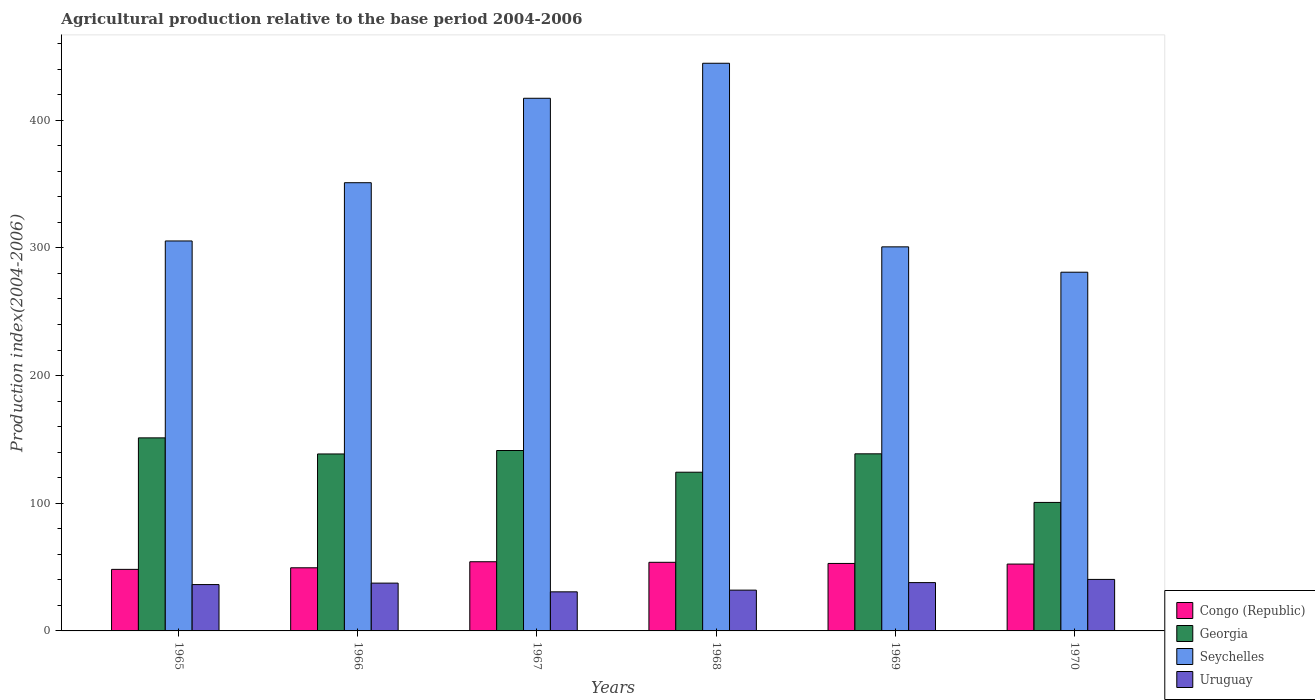How many different coloured bars are there?
Your answer should be compact. 4. Are the number of bars on each tick of the X-axis equal?
Offer a terse response. Yes. In how many cases, is the number of bars for a given year not equal to the number of legend labels?
Offer a terse response. 0. What is the agricultural production index in Uruguay in 1968?
Provide a succinct answer. 31.95. Across all years, what is the maximum agricultural production index in Congo (Republic)?
Your answer should be very brief. 54.18. Across all years, what is the minimum agricultural production index in Uruguay?
Make the answer very short. 30.61. In which year was the agricultural production index in Seychelles maximum?
Make the answer very short. 1968. In which year was the agricultural production index in Seychelles minimum?
Provide a short and direct response. 1970. What is the total agricultural production index in Uruguay in the graph?
Offer a very short reply. 214.48. What is the difference between the agricultural production index in Congo (Republic) in 1967 and that in 1970?
Keep it short and to the point. 1.82. What is the difference between the agricultural production index in Seychelles in 1966 and the agricultural production index in Uruguay in 1967?
Ensure brevity in your answer.  320.42. What is the average agricultural production index in Congo (Republic) per year?
Your answer should be compact. 51.8. In the year 1968, what is the difference between the agricultural production index in Congo (Republic) and agricultural production index in Georgia?
Keep it short and to the point. -70.56. What is the ratio of the agricultural production index in Congo (Republic) in 1965 to that in 1967?
Give a very brief answer. 0.89. What is the difference between the highest and the second highest agricultural production index in Congo (Republic)?
Provide a succinct answer. 0.44. What is the difference between the highest and the lowest agricultural production index in Uruguay?
Your answer should be compact. 9.73. In how many years, is the agricultural production index in Uruguay greater than the average agricultural production index in Uruguay taken over all years?
Your answer should be very brief. 4. Is the sum of the agricultural production index in Georgia in 1966 and 1969 greater than the maximum agricultural production index in Congo (Republic) across all years?
Your answer should be very brief. Yes. Is it the case that in every year, the sum of the agricultural production index in Uruguay and agricultural production index in Seychelles is greater than the sum of agricultural production index in Georgia and agricultural production index in Congo (Republic)?
Provide a succinct answer. Yes. What does the 4th bar from the left in 1970 represents?
Make the answer very short. Uruguay. What does the 2nd bar from the right in 1967 represents?
Make the answer very short. Seychelles. Is it the case that in every year, the sum of the agricultural production index in Congo (Republic) and agricultural production index in Seychelles is greater than the agricultural production index in Uruguay?
Your answer should be compact. Yes. How many bars are there?
Keep it short and to the point. 24. Are all the bars in the graph horizontal?
Ensure brevity in your answer.  No. Does the graph contain any zero values?
Make the answer very short. No. How are the legend labels stacked?
Provide a succinct answer. Vertical. What is the title of the graph?
Offer a very short reply. Agricultural production relative to the base period 2004-2006. Does "Moldova" appear as one of the legend labels in the graph?
Your answer should be compact. No. What is the label or title of the Y-axis?
Provide a succinct answer. Production index(2004-2006). What is the Production index(2004-2006) in Congo (Republic) in 1965?
Offer a terse response. 48.21. What is the Production index(2004-2006) in Georgia in 1965?
Offer a very short reply. 151.2. What is the Production index(2004-2006) of Seychelles in 1965?
Give a very brief answer. 305.41. What is the Production index(2004-2006) in Uruguay in 1965?
Make the answer very short. 36.3. What is the Production index(2004-2006) in Congo (Republic) in 1966?
Keep it short and to the point. 49.44. What is the Production index(2004-2006) in Georgia in 1966?
Give a very brief answer. 138.6. What is the Production index(2004-2006) in Seychelles in 1966?
Offer a very short reply. 351.03. What is the Production index(2004-2006) of Uruguay in 1966?
Offer a terse response. 37.44. What is the Production index(2004-2006) of Congo (Republic) in 1967?
Your answer should be compact. 54.18. What is the Production index(2004-2006) of Georgia in 1967?
Offer a terse response. 141.3. What is the Production index(2004-2006) of Seychelles in 1967?
Offer a terse response. 417.17. What is the Production index(2004-2006) of Uruguay in 1967?
Give a very brief answer. 30.61. What is the Production index(2004-2006) in Congo (Republic) in 1968?
Provide a succinct answer. 53.74. What is the Production index(2004-2006) of Georgia in 1968?
Your response must be concise. 124.3. What is the Production index(2004-2006) in Seychelles in 1968?
Your response must be concise. 444.59. What is the Production index(2004-2006) in Uruguay in 1968?
Offer a very short reply. 31.95. What is the Production index(2004-2006) in Congo (Republic) in 1969?
Provide a succinct answer. 52.85. What is the Production index(2004-2006) in Georgia in 1969?
Your answer should be very brief. 138.7. What is the Production index(2004-2006) of Seychelles in 1969?
Your answer should be very brief. 300.8. What is the Production index(2004-2006) of Uruguay in 1969?
Ensure brevity in your answer.  37.84. What is the Production index(2004-2006) of Congo (Republic) in 1970?
Provide a short and direct response. 52.36. What is the Production index(2004-2006) in Georgia in 1970?
Make the answer very short. 100.63. What is the Production index(2004-2006) of Seychelles in 1970?
Ensure brevity in your answer.  280.94. What is the Production index(2004-2006) of Uruguay in 1970?
Your response must be concise. 40.34. Across all years, what is the maximum Production index(2004-2006) of Congo (Republic)?
Offer a terse response. 54.18. Across all years, what is the maximum Production index(2004-2006) of Georgia?
Your answer should be very brief. 151.2. Across all years, what is the maximum Production index(2004-2006) of Seychelles?
Offer a very short reply. 444.59. Across all years, what is the maximum Production index(2004-2006) in Uruguay?
Ensure brevity in your answer.  40.34. Across all years, what is the minimum Production index(2004-2006) in Congo (Republic)?
Give a very brief answer. 48.21. Across all years, what is the minimum Production index(2004-2006) in Georgia?
Offer a terse response. 100.63. Across all years, what is the minimum Production index(2004-2006) in Seychelles?
Provide a short and direct response. 280.94. Across all years, what is the minimum Production index(2004-2006) in Uruguay?
Provide a succinct answer. 30.61. What is the total Production index(2004-2006) of Congo (Republic) in the graph?
Offer a terse response. 310.78. What is the total Production index(2004-2006) in Georgia in the graph?
Keep it short and to the point. 794.73. What is the total Production index(2004-2006) of Seychelles in the graph?
Offer a very short reply. 2099.94. What is the total Production index(2004-2006) in Uruguay in the graph?
Your response must be concise. 214.48. What is the difference between the Production index(2004-2006) in Congo (Republic) in 1965 and that in 1966?
Keep it short and to the point. -1.23. What is the difference between the Production index(2004-2006) of Georgia in 1965 and that in 1966?
Your response must be concise. 12.6. What is the difference between the Production index(2004-2006) in Seychelles in 1965 and that in 1966?
Your answer should be very brief. -45.62. What is the difference between the Production index(2004-2006) of Uruguay in 1965 and that in 1966?
Give a very brief answer. -1.14. What is the difference between the Production index(2004-2006) of Congo (Republic) in 1965 and that in 1967?
Provide a succinct answer. -5.97. What is the difference between the Production index(2004-2006) in Seychelles in 1965 and that in 1967?
Offer a very short reply. -111.76. What is the difference between the Production index(2004-2006) in Uruguay in 1965 and that in 1967?
Offer a very short reply. 5.69. What is the difference between the Production index(2004-2006) in Congo (Republic) in 1965 and that in 1968?
Provide a short and direct response. -5.53. What is the difference between the Production index(2004-2006) of Georgia in 1965 and that in 1968?
Offer a terse response. 26.9. What is the difference between the Production index(2004-2006) in Seychelles in 1965 and that in 1968?
Your response must be concise. -139.18. What is the difference between the Production index(2004-2006) of Uruguay in 1965 and that in 1968?
Your response must be concise. 4.35. What is the difference between the Production index(2004-2006) of Congo (Republic) in 1965 and that in 1969?
Provide a succinct answer. -4.64. What is the difference between the Production index(2004-2006) of Georgia in 1965 and that in 1969?
Give a very brief answer. 12.5. What is the difference between the Production index(2004-2006) in Seychelles in 1965 and that in 1969?
Make the answer very short. 4.61. What is the difference between the Production index(2004-2006) in Uruguay in 1965 and that in 1969?
Your answer should be very brief. -1.54. What is the difference between the Production index(2004-2006) of Congo (Republic) in 1965 and that in 1970?
Make the answer very short. -4.15. What is the difference between the Production index(2004-2006) in Georgia in 1965 and that in 1970?
Provide a short and direct response. 50.57. What is the difference between the Production index(2004-2006) of Seychelles in 1965 and that in 1970?
Your answer should be compact. 24.47. What is the difference between the Production index(2004-2006) in Uruguay in 1965 and that in 1970?
Your answer should be very brief. -4.04. What is the difference between the Production index(2004-2006) in Congo (Republic) in 1966 and that in 1967?
Provide a short and direct response. -4.74. What is the difference between the Production index(2004-2006) in Seychelles in 1966 and that in 1967?
Keep it short and to the point. -66.14. What is the difference between the Production index(2004-2006) of Uruguay in 1966 and that in 1967?
Give a very brief answer. 6.83. What is the difference between the Production index(2004-2006) in Congo (Republic) in 1966 and that in 1968?
Give a very brief answer. -4.3. What is the difference between the Production index(2004-2006) in Seychelles in 1966 and that in 1968?
Offer a very short reply. -93.56. What is the difference between the Production index(2004-2006) of Uruguay in 1966 and that in 1968?
Make the answer very short. 5.49. What is the difference between the Production index(2004-2006) in Congo (Republic) in 1966 and that in 1969?
Give a very brief answer. -3.41. What is the difference between the Production index(2004-2006) in Georgia in 1966 and that in 1969?
Your answer should be compact. -0.1. What is the difference between the Production index(2004-2006) in Seychelles in 1966 and that in 1969?
Your response must be concise. 50.23. What is the difference between the Production index(2004-2006) of Uruguay in 1966 and that in 1969?
Your response must be concise. -0.4. What is the difference between the Production index(2004-2006) in Congo (Republic) in 1966 and that in 1970?
Provide a short and direct response. -2.92. What is the difference between the Production index(2004-2006) in Georgia in 1966 and that in 1970?
Ensure brevity in your answer.  37.97. What is the difference between the Production index(2004-2006) in Seychelles in 1966 and that in 1970?
Provide a short and direct response. 70.09. What is the difference between the Production index(2004-2006) of Congo (Republic) in 1967 and that in 1968?
Keep it short and to the point. 0.44. What is the difference between the Production index(2004-2006) of Georgia in 1967 and that in 1968?
Provide a succinct answer. 17. What is the difference between the Production index(2004-2006) in Seychelles in 1967 and that in 1968?
Give a very brief answer. -27.42. What is the difference between the Production index(2004-2006) of Uruguay in 1967 and that in 1968?
Offer a terse response. -1.34. What is the difference between the Production index(2004-2006) of Congo (Republic) in 1967 and that in 1969?
Ensure brevity in your answer.  1.33. What is the difference between the Production index(2004-2006) of Georgia in 1967 and that in 1969?
Offer a very short reply. 2.6. What is the difference between the Production index(2004-2006) in Seychelles in 1967 and that in 1969?
Your answer should be compact. 116.37. What is the difference between the Production index(2004-2006) of Uruguay in 1967 and that in 1969?
Keep it short and to the point. -7.23. What is the difference between the Production index(2004-2006) in Congo (Republic) in 1967 and that in 1970?
Make the answer very short. 1.82. What is the difference between the Production index(2004-2006) of Georgia in 1967 and that in 1970?
Provide a succinct answer. 40.67. What is the difference between the Production index(2004-2006) in Seychelles in 1967 and that in 1970?
Keep it short and to the point. 136.23. What is the difference between the Production index(2004-2006) of Uruguay in 1967 and that in 1970?
Make the answer very short. -9.73. What is the difference between the Production index(2004-2006) in Congo (Republic) in 1968 and that in 1969?
Make the answer very short. 0.89. What is the difference between the Production index(2004-2006) of Georgia in 1968 and that in 1969?
Your response must be concise. -14.4. What is the difference between the Production index(2004-2006) of Seychelles in 1968 and that in 1969?
Provide a succinct answer. 143.79. What is the difference between the Production index(2004-2006) in Uruguay in 1968 and that in 1969?
Keep it short and to the point. -5.89. What is the difference between the Production index(2004-2006) of Congo (Republic) in 1968 and that in 1970?
Make the answer very short. 1.38. What is the difference between the Production index(2004-2006) of Georgia in 1968 and that in 1970?
Offer a terse response. 23.67. What is the difference between the Production index(2004-2006) in Seychelles in 1968 and that in 1970?
Your answer should be compact. 163.65. What is the difference between the Production index(2004-2006) of Uruguay in 1968 and that in 1970?
Provide a short and direct response. -8.39. What is the difference between the Production index(2004-2006) of Congo (Republic) in 1969 and that in 1970?
Provide a short and direct response. 0.49. What is the difference between the Production index(2004-2006) of Georgia in 1969 and that in 1970?
Give a very brief answer. 38.07. What is the difference between the Production index(2004-2006) in Seychelles in 1969 and that in 1970?
Offer a very short reply. 19.86. What is the difference between the Production index(2004-2006) of Uruguay in 1969 and that in 1970?
Provide a short and direct response. -2.5. What is the difference between the Production index(2004-2006) in Congo (Republic) in 1965 and the Production index(2004-2006) in Georgia in 1966?
Keep it short and to the point. -90.39. What is the difference between the Production index(2004-2006) of Congo (Republic) in 1965 and the Production index(2004-2006) of Seychelles in 1966?
Your answer should be very brief. -302.82. What is the difference between the Production index(2004-2006) of Congo (Republic) in 1965 and the Production index(2004-2006) of Uruguay in 1966?
Offer a terse response. 10.77. What is the difference between the Production index(2004-2006) of Georgia in 1965 and the Production index(2004-2006) of Seychelles in 1966?
Offer a terse response. -199.83. What is the difference between the Production index(2004-2006) of Georgia in 1965 and the Production index(2004-2006) of Uruguay in 1966?
Keep it short and to the point. 113.76. What is the difference between the Production index(2004-2006) in Seychelles in 1965 and the Production index(2004-2006) in Uruguay in 1966?
Your answer should be very brief. 267.97. What is the difference between the Production index(2004-2006) in Congo (Republic) in 1965 and the Production index(2004-2006) in Georgia in 1967?
Offer a very short reply. -93.09. What is the difference between the Production index(2004-2006) in Congo (Republic) in 1965 and the Production index(2004-2006) in Seychelles in 1967?
Offer a terse response. -368.96. What is the difference between the Production index(2004-2006) of Georgia in 1965 and the Production index(2004-2006) of Seychelles in 1967?
Make the answer very short. -265.97. What is the difference between the Production index(2004-2006) in Georgia in 1965 and the Production index(2004-2006) in Uruguay in 1967?
Give a very brief answer. 120.59. What is the difference between the Production index(2004-2006) in Seychelles in 1965 and the Production index(2004-2006) in Uruguay in 1967?
Your response must be concise. 274.8. What is the difference between the Production index(2004-2006) in Congo (Republic) in 1965 and the Production index(2004-2006) in Georgia in 1968?
Your answer should be very brief. -76.09. What is the difference between the Production index(2004-2006) in Congo (Republic) in 1965 and the Production index(2004-2006) in Seychelles in 1968?
Keep it short and to the point. -396.38. What is the difference between the Production index(2004-2006) of Congo (Republic) in 1965 and the Production index(2004-2006) of Uruguay in 1968?
Keep it short and to the point. 16.26. What is the difference between the Production index(2004-2006) in Georgia in 1965 and the Production index(2004-2006) in Seychelles in 1968?
Keep it short and to the point. -293.39. What is the difference between the Production index(2004-2006) in Georgia in 1965 and the Production index(2004-2006) in Uruguay in 1968?
Ensure brevity in your answer.  119.25. What is the difference between the Production index(2004-2006) of Seychelles in 1965 and the Production index(2004-2006) of Uruguay in 1968?
Your answer should be very brief. 273.46. What is the difference between the Production index(2004-2006) in Congo (Republic) in 1965 and the Production index(2004-2006) in Georgia in 1969?
Your answer should be compact. -90.49. What is the difference between the Production index(2004-2006) in Congo (Republic) in 1965 and the Production index(2004-2006) in Seychelles in 1969?
Make the answer very short. -252.59. What is the difference between the Production index(2004-2006) of Congo (Republic) in 1965 and the Production index(2004-2006) of Uruguay in 1969?
Ensure brevity in your answer.  10.37. What is the difference between the Production index(2004-2006) in Georgia in 1965 and the Production index(2004-2006) in Seychelles in 1969?
Provide a short and direct response. -149.6. What is the difference between the Production index(2004-2006) in Georgia in 1965 and the Production index(2004-2006) in Uruguay in 1969?
Keep it short and to the point. 113.36. What is the difference between the Production index(2004-2006) in Seychelles in 1965 and the Production index(2004-2006) in Uruguay in 1969?
Give a very brief answer. 267.57. What is the difference between the Production index(2004-2006) of Congo (Republic) in 1965 and the Production index(2004-2006) of Georgia in 1970?
Give a very brief answer. -52.42. What is the difference between the Production index(2004-2006) in Congo (Republic) in 1965 and the Production index(2004-2006) in Seychelles in 1970?
Your response must be concise. -232.73. What is the difference between the Production index(2004-2006) of Congo (Republic) in 1965 and the Production index(2004-2006) of Uruguay in 1970?
Keep it short and to the point. 7.87. What is the difference between the Production index(2004-2006) in Georgia in 1965 and the Production index(2004-2006) in Seychelles in 1970?
Provide a short and direct response. -129.74. What is the difference between the Production index(2004-2006) of Georgia in 1965 and the Production index(2004-2006) of Uruguay in 1970?
Your answer should be very brief. 110.86. What is the difference between the Production index(2004-2006) of Seychelles in 1965 and the Production index(2004-2006) of Uruguay in 1970?
Give a very brief answer. 265.07. What is the difference between the Production index(2004-2006) in Congo (Republic) in 1966 and the Production index(2004-2006) in Georgia in 1967?
Keep it short and to the point. -91.86. What is the difference between the Production index(2004-2006) of Congo (Republic) in 1966 and the Production index(2004-2006) of Seychelles in 1967?
Provide a short and direct response. -367.73. What is the difference between the Production index(2004-2006) in Congo (Republic) in 1966 and the Production index(2004-2006) in Uruguay in 1967?
Your response must be concise. 18.83. What is the difference between the Production index(2004-2006) of Georgia in 1966 and the Production index(2004-2006) of Seychelles in 1967?
Give a very brief answer. -278.57. What is the difference between the Production index(2004-2006) of Georgia in 1966 and the Production index(2004-2006) of Uruguay in 1967?
Keep it short and to the point. 107.99. What is the difference between the Production index(2004-2006) of Seychelles in 1966 and the Production index(2004-2006) of Uruguay in 1967?
Your response must be concise. 320.42. What is the difference between the Production index(2004-2006) of Congo (Republic) in 1966 and the Production index(2004-2006) of Georgia in 1968?
Your response must be concise. -74.86. What is the difference between the Production index(2004-2006) in Congo (Republic) in 1966 and the Production index(2004-2006) in Seychelles in 1968?
Make the answer very short. -395.15. What is the difference between the Production index(2004-2006) in Congo (Republic) in 1966 and the Production index(2004-2006) in Uruguay in 1968?
Keep it short and to the point. 17.49. What is the difference between the Production index(2004-2006) of Georgia in 1966 and the Production index(2004-2006) of Seychelles in 1968?
Ensure brevity in your answer.  -305.99. What is the difference between the Production index(2004-2006) in Georgia in 1966 and the Production index(2004-2006) in Uruguay in 1968?
Your answer should be compact. 106.65. What is the difference between the Production index(2004-2006) in Seychelles in 1966 and the Production index(2004-2006) in Uruguay in 1968?
Make the answer very short. 319.08. What is the difference between the Production index(2004-2006) of Congo (Republic) in 1966 and the Production index(2004-2006) of Georgia in 1969?
Provide a short and direct response. -89.26. What is the difference between the Production index(2004-2006) in Congo (Republic) in 1966 and the Production index(2004-2006) in Seychelles in 1969?
Provide a short and direct response. -251.36. What is the difference between the Production index(2004-2006) of Georgia in 1966 and the Production index(2004-2006) of Seychelles in 1969?
Your response must be concise. -162.2. What is the difference between the Production index(2004-2006) of Georgia in 1966 and the Production index(2004-2006) of Uruguay in 1969?
Provide a short and direct response. 100.76. What is the difference between the Production index(2004-2006) in Seychelles in 1966 and the Production index(2004-2006) in Uruguay in 1969?
Offer a very short reply. 313.19. What is the difference between the Production index(2004-2006) of Congo (Republic) in 1966 and the Production index(2004-2006) of Georgia in 1970?
Make the answer very short. -51.19. What is the difference between the Production index(2004-2006) in Congo (Republic) in 1966 and the Production index(2004-2006) in Seychelles in 1970?
Keep it short and to the point. -231.5. What is the difference between the Production index(2004-2006) in Congo (Republic) in 1966 and the Production index(2004-2006) in Uruguay in 1970?
Offer a very short reply. 9.1. What is the difference between the Production index(2004-2006) of Georgia in 1966 and the Production index(2004-2006) of Seychelles in 1970?
Offer a very short reply. -142.34. What is the difference between the Production index(2004-2006) in Georgia in 1966 and the Production index(2004-2006) in Uruguay in 1970?
Give a very brief answer. 98.26. What is the difference between the Production index(2004-2006) in Seychelles in 1966 and the Production index(2004-2006) in Uruguay in 1970?
Make the answer very short. 310.69. What is the difference between the Production index(2004-2006) of Congo (Republic) in 1967 and the Production index(2004-2006) of Georgia in 1968?
Give a very brief answer. -70.12. What is the difference between the Production index(2004-2006) in Congo (Republic) in 1967 and the Production index(2004-2006) in Seychelles in 1968?
Your answer should be very brief. -390.41. What is the difference between the Production index(2004-2006) in Congo (Republic) in 1967 and the Production index(2004-2006) in Uruguay in 1968?
Make the answer very short. 22.23. What is the difference between the Production index(2004-2006) in Georgia in 1967 and the Production index(2004-2006) in Seychelles in 1968?
Your answer should be compact. -303.29. What is the difference between the Production index(2004-2006) of Georgia in 1967 and the Production index(2004-2006) of Uruguay in 1968?
Make the answer very short. 109.35. What is the difference between the Production index(2004-2006) in Seychelles in 1967 and the Production index(2004-2006) in Uruguay in 1968?
Your answer should be very brief. 385.22. What is the difference between the Production index(2004-2006) in Congo (Republic) in 1967 and the Production index(2004-2006) in Georgia in 1969?
Offer a terse response. -84.52. What is the difference between the Production index(2004-2006) of Congo (Republic) in 1967 and the Production index(2004-2006) of Seychelles in 1969?
Your answer should be compact. -246.62. What is the difference between the Production index(2004-2006) of Congo (Republic) in 1967 and the Production index(2004-2006) of Uruguay in 1969?
Make the answer very short. 16.34. What is the difference between the Production index(2004-2006) of Georgia in 1967 and the Production index(2004-2006) of Seychelles in 1969?
Provide a short and direct response. -159.5. What is the difference between the Production index(2004-2006) of Georgia in 1967 and the Production index(2004-2006) of Uruguay in 1969?
Offer a terse response. 103.46. What is the difference between the Production index(2004-2006) in Seychelles in 1967 and the Production index(2004-2006) in Uruguay in 1969?
Offer a very short reply. 379.33. What is the difference between the Production index(2004-2006) of Congo (Republic) in 1967 and the Production index(2004-2006) of Georgia in 1970?
Your answer should be very brief. -46.45. What is the difference between the Production index(2004-2006) in Congo (Republic) in 1967 and the Production index(2004-2006) in Seychelles in 1970?
Keep it short and to the point. -226.76. What is the difference between the Production index(2004-2006) in Congo (Republic) in 1967 and the Production index(2004-2006) in Uruguay in 1970?
Provide a short and direct response. 13.84. What is the difference between the Production index(2004-2006) in Georgia in 1967 and the Production index(2004-2006) in Seychelles in 1970?
Keep it short and to the point. -139.64. What is the difference between the Production index(2004-2006) in Georgia in 1967 and the Production index(2004-2006) in Uruguay in 1970?
Ensure brevity in your answer.  100.96. What is the difference between the Production index(2004-2006) of Seychelles in 1967 and the Production index(2004-2006) of Uruguay in 1970?
Ensure brevity in your answer.  376.83. What is the difference between the Production index(2004-2006) of Congo (Republic) in 1968 and the Production index(2004-2006) of Georgia in 1969?
Ensure brevity in your answer.  -84.96. What is the difference between the Production index(2004-2006) in Congo (Republic) in 1968 and the Production index(2004-2006) in Seychelles in 1969?
Keep it short and to the point. -247.06. What is the difference between the Production index(2004-2006) of Georgia in 1968 and the Production index(2004-2006) of Seychelles in 1969?
Offer a terse response. -176.5. What is the difference between the Production index(2004-2006) in Georgia in 1968 and the Production index(2004-2006) in Uruguay in 1969?
Ensure brevity in your answer.  86.46. What is the difference between the Production index(2004-2006) in Seychelles in 1968 and the Production index(2004-2006) in Uruguay in 1969?
Your answer should be compact. 406.75. What is the difference between the Production index(2004-2006) in Congo (Republic) in 1968 and the Production index(2004-2006) in Georgia in 1970?
Your response must be concise. -46.89. What is the difference between the Production index(2004-2006) of Congo (Republic) in 1968 and the Production index(2004-2006) of Seychelles in 1970?
Ensure brevity in your answer.  -227.2. What is the difference between the Production index(2004-2006) of Congo (Republic) in 1968 and the Production index(2004-2006) of Uruguay in 1970?
Your answer should be very brief. 13.4. What is the difference between the Production index(2004-2006) of Georgia in 1968 and the Production index(2004-2006) of Seychelles in 1970?
Provide a succinct answer. -156.64. What is the difference between the Production index(2004-2006) of Georgia in 1968 and the Production index(2004-2006) of Uruguay in 1970?
Provide a short and direct response. 83.96. What is the difference between the Production index(2004-2006) of Seychelles in 1968 and the Production index(2004-2006) of Uruguay in 1970?
Ensure brevity in your answer.  404.25. What is the difference between the Production index(2004-2006) in Congo (Republic) in 1969 and the Production index(2004-2006) in Georgia in 1970?
Your response must be concise. -47.78. What is the difference between the Production index(2004-2006) in Congo (Republic) in 1969 and the Production index(2004-2006) in Seychelles in 1970?
Your response must be concise. -228.09. What is the difference between the Production index(2004-2006) of Congo (Republic) in 1969 and the Production index(2004-2006) of Uruguay in 1970?
Your response must be concise. 12.51. What is the difference between the Production index(2004-2006) in Georgia in 1969 and the Production index(2004-2006) in Seychelles in 1970?
Offer a terse response. -142.24. What is the difference between the Production index(2004-2006) in Georgia in 1969 and the Production index(2004-2006) in Uruguay in 1970?
Offer a very short reply. 98.36. What is the difference between the Production index(2004-2006) of Seychelles in 1969 and the Production index(2004-2006) of Uruguay in 1970?
Your response must be concise. 260.46. What is the average Production index(2004-2006) of Congo (Republic) per year?
Make the answer very short. 51.8. What is the average Production index(2004-2006) of Georgia per year?
Your answer should be compact. 132.46. What is the average Production index(2004-2006) in Seychelles per year?
Offer a terse response. 349.99. What is the average Production index(2004-2006) of Uruguay per year?
Ensure brevity in your answer.  35.75. In the year 1965, what is the difference between the Production index(2004-2006) in Congo (Republic) and Production index(2004-2006) in Georgia?
Offer a terse response. -102.99. In the year 1965, what is the difference between the Production index(2004-2006) of Congo (Republic) and Production index(2004-2006) of Seychelles?
Your answer should be very brief. -257.2. In the year 1965, what is the difference between the Production index(2004-2006) in Congo (Republic) and Production index(2004-2006) in Uruguay?
Make the answer very short. 11.91. In the year 1965, what is the difference between the Production index(2004-2006) in Georgia and Production index(2004-2006) in Seychelles?
Your answer should be compact. -154.21. In the year 1965, what is the difference between the Production index(2004-2006) of Georgia and Production index(2004-2006) of Uruguay?
Offer a very short reply. 114.9. In the year 1965, what is the difference between the Production index(2004-2006) in Seychelles and Production index(2004-2006) in Uruguay?
Keep it short and to the point. 269.11. In the year 1966, what is the difference between the Production index(2004-2006) in Congo (Republic) and Production index(2004-2006) in Georgia?
Your answer should be very brief. -89.16. In the year 1966, what is the difference between the Production index(2004-2006) of Congo (Republic) and Production index(2004-2006) of Seychelles?
Your answer should be very brief. -301.59. In the year 1966, what is the difference between the Production index(2004-2006) in Georgia and Production index(2004-2006) in Seychelles?
Give a very brief answer. -212.43. In the year 1966, what is the difference between the Production index(2004-2006) of Georgia and Production index(2004-2006) of Uruguay?
Ensure brevity in your answer.  101.16. In the year 1966, what is the difference between the Production index(2004-2006) in Seychelles and Production index(2004-2006) in Uruguay?
Your response must be concise. 313.59. In the year 1967, what is the difference between the Production index(2004-2006) in Congo (Republic) and Production index(2004-2006) in Georgia?
Offer a very short reply. -87.12. In the year 1967, what is the difference between the Production index(2004-2006) of Congo (Republic) and Production index(2004-2006) of Seychelles?
Provide a succinct answer. -362.99. In the year 1967, what is the difference between the Production index(2004-2006) of Congo (Republic) and Production index(2004-2006) of Uruguay?
Ensure brevity in your answer.  23.57. In the year 1967, what is the difference between the Production index(2004-2006) in Georgia and Production index(2004-2006) in Seychelles?
Provide a short and direct response. -275.87. In the year 1967, what is the difference between the Production index(2004-2006) in Georgia and Production index(2004-2006) in Uruguay?
Ensure brevity in your answer.  110.69. In the year 1967, what is the difference between the Production index(2004-2006) in Seychelles and Production index(2004-2006) in Uruguay?
Offer a terse response. 386.56. In the year 1968, what is the difference between the Production index(2004-2006) in Congo (Republic) and Production index(2004-2006) in Georgia?
Offer a very short reply. -70.56. In the year 1968, what is the difference between the Production index(2004-2006) of Congo (Republic) and Production index(2004-2006) of Seychelles?
Offer a very short reply. -390.85. In the year 1968, what is the difference between the Production index(2004-2006) of Congo (Republic) and Production index(2004-2006) of Uruguay?
Your answer should be compact. 21.79. In the year 1968, what is the difference between the Production index(2004-2006) in Georgia and Production index(2004-2006) in Seychelles?
Your response must be concise. -320.29. In the year 1968, what is the difference between the Production index(2004-2006) of Georgia and Production index(2004-2006) of Uruguay?
Provide a short and direct response. 92.35. In the year 1968, what is the difference between the Production index(2004-2006) in Seychelles and Production index(2004-2006) in Uruguay?
Your response must be concise. 412.64. In the year 1969, what is the difference between the Production index(2004-2006) in Congo (Republic) and Production index(2004-2006) in Georgia?
Your answer should be very brief. -85.85. In the year 1969, what is the difference between the Production index(2004-2006) in Congo (Republic) and Production index(2004-2006) in Seychelles?
Provide a short and direct response. -247.95. In the year 1969, what is the difference between the Production index(2004-2006) in Congo (Republic) and Production index(2004-2006) in Uruguay?
Your answer should be very brief. 15.01. In the year 1969, what is the difference between the Production index(2004-2006) of Georgia and Production index(2004-2006) of Seychelles?
Ensure brevity in your answer.  -162.1. In the year 1969, what is the difference between the Production index(2004-2006) in Georgia and Production index(2004-2006) in Uruguay?
Offer a very short reply. 100.86. In the year 1969, what is the difference between the Production index(2004-2006) of Seychelles and Production index(2004-2006) of Uruguay?
Ensure brevity in your answer.  262.96. In the year 1970, what is the difference between the Production index(2004-2006) in Congo (Republic) and Production index(2004-2006) in Georgia?
Make the answer very short. -48.27. In the year 1970, what is the difference between the Production index(2004-2006) in Congo (Republic) and Production index(2004-2006) in Seychelles?
Your answer should be compact. -228.58. In the year 1970, what is the difference between the Production index(2004-2006) in Congo (Republic) and Production index(2004-2006) in Uruguay?
Offer a terse response. 12.02. In the year 1970, what is the difference between the Production index(2004-2006) of Georgia and Production index(2004-2006) of Seychelles?
Provide a succinct answer. -180.31. In the year 1970, what is the difference between the Production index(2004-2006) in Georgia and Production index(2004-2006) in Uruguay?
Provide a short and direct response. 60.29. In the year 1970, what is the difference between the Production index(2004-2006) in Seychelles and Production index(2004-2006) in Uruguay?
Keep it short and to the point. 240.6. What is the ratio of the Production index(2004-2006) in Congo (Republic) in 1965 to that in 1966?
Offer a terse response. 0.98. What is the ratio of the Production index(2004-2006) in Georgia in 1965 to that in 1966?
Provide a short and direct response. 1.09. What is the ratio of the Production index(2004-2006) of Seychelles in 1965 to that in 1966?
Make the answer very short. 0.87. What is the ratio of the Production index(2004-2006) of Uruguay in 1965 to that in 1966?
Provide a succinct answer. 0.97. What is the ratio of the Production index(2004-2006) of Congo (Republic) in 1965 to that in 1967?
Offer a terse response. 0.89. What is the ratio of the Production index(2004-2006) in Georgia in 1965 to that in 1967?
Offer a very short reply. 1.07. What is the ratio of the Production index(2004-2006) of Seychelles in 1965 to that in 1967?
Offer a terse response. 0.73. What is the ratio of the Production index(2004-2006) in Uruguay in 1965 to that in 1967?
Give a very brief answer. 1.19. What is the ratio of the Production index(2004-2006) in Congo (Republic) in 1965 to that in 1968?
Your answer should be very brief. 0.9. What is the ratio of the Production index(2004-2006) in Georgia in 1965 to that in 1968?
Make the answer very short. 1.22. What is the ratio of the Production index(2004-2006) in Seychelles in 1965 to that in 1968?
Your answer should be very brief. 0.69. What is the ratio of the Production index(2004-2006) in Uruguay in 1965 to that in 1968?
Give a very brief answer. 1.14. What is the ratio of the Production index(2004-2006) in Congo (Republic) in 1965 to that in 1969?
Ensure brevity in your answer.  0.91. What is the ratio of the Production index(2004-2006) of Georgia in 1965 to that in 1969?
Your response must be concise. 1.09. What is the ratio of the Production index(2004-2006) of Seychelles in 1965 to that in 1969?
Ensure brevity in your answer.  1.02. What is the ratio of the Production index(2004-2006) of Uruguay in 1965 to that in 1969?
Provide a succinct answer. 0.96. What is the ratio of the Production index(2004-2006) in Congo (Republic) in 1965 to that in 1970?
Your response must be concise. 0.92. What is the ratio of the Production index(2004-2006) of Georgia in 1965 to that in 1970?
Provide a short and direct response. 1.5. What is the ratio of the Production index(2004-2006) in Seychelles in 1965 to that in 1970?
Your answer should be compact. 1.09. What is the ratio of the Production index(2004-2006) in Uruguay in 1965 to that in 1970?
Make the answer very short. 0.9. What is the ratio of the Production index(2004-2006) of Congo (Republic) in 1966 to that in 1967?
Provide a succinct answer. 0.91. What is the ratio of the Production index(2004-2006) of Georgia in 1966 to that in 1967?
Provide a succinct answer. 0.98. What is the ratio of the Production index(2004-2006) of Seychelles in 1966 to that in 1967?
Give a very brief answer. 0.84. What is the ratio of the Production index(2004-2006) in Uruguay in 1966 to that in 1967?
Make the answer very short. 1.22. What is the ratio of the Production index(2004-2006) of Georgia in 1966 to that in 1968?
Provide a short and direct response. 1.11. What is the ratio of the Production index(2004-2006) in Seychelles in 1966 to that in 1968?
Ensure brevity in your answer.  0.79. What is the ratio of the Production index(2004-2006) in Uruguay in 1966 to that in 1968?
Provide a short and direct response. 1.17. What is the ratio of the Production index(2004-2006) of Congo (Republic) in 1966 to that in 1969?
Make the answer very short. 0.94. What is the ratio of the Production index(2004-2006) of Georgia in 1966 to that in 1969?
Provide a short and direct response. 1. What is the ratio of the Production index(2004-2006) of Seychelles in 1966 to that in 1969?
Make the answer very short. 1.17. What is the ratio of the Production index(2004-2006) of Uruguay in 1966 to that in 1969?
Provide a short and direct response. 0.99. What is the ratio of the Production index(2004-2006) of Congo (Republic) in 1966 to that in 1970?
Provide a succinct answer. 0.94. What is the ratio of the Production index(2004-2006) of Georgia in 1966 to that in 1970?
Your answer should be very brief. 1.38. What is the ratio of the Production index(2004-2006) in Seychelles in 1966 to that in 1970?
Your response must be concise. 1.25. What is the ratio of the Production index(2004-2006) of Uruguay in 1966 to that in 1970?
Keep it short and to the point. 0.93. What is the ratio of the Production index(2004-2006) of Congo (Republic) in 1967 to that in 1968?
Provide a succinct answer. 1.01. What is the ratio of the Production index(2004-2006) of Georgia in 1967 to that in 1968?
Offer a very short reply. 1.14. What is the ratio of the Production index(2004-2006) in Seychelles in 1967 to that in 1968?
Ensure brevity in your answer.  0.94. What is the ratio of the Production index(2004-2006) in Uruguay in 1967 to that in 1968?
Make the answer very short. 0.96. What is the ratio of the Production index(2004-2006) of Congo (Republic) in 1967 to that in 1969?
Keep it short and to the point. 1.03. What is the ratio of the Production index(2004-2006) of Georgia in 1967 to that in 1969?
Provide a short and direct response. 1.02. What is the ratio of the Production index(2004-2006) in Seychelles in 1967 to that in 1969?
Offer a terse response. 1.39. What is the ratio of the Production index(2004-2006) of Uruguay in 1967 to that in 1969?
Provide a succinct answer. 0.81. What is the ratio of the Production index(2004-2006) of Congo (Republic) in 1967 to that in 1970?
Ensure brevity in your answer.  1.03. What is the ratio of the Production index(2004-2006) in Georgia in 1967 to that in 1970?
Offer a terse response. 1.4. What is the ratio of the Production index(2004-2006) in Seychelles in 1967 to that in 1970?
Provide a succinct answer. 1.48. What is the ratio of the Production index(2004-2006) of Uruguay in 1967 to that in 1970?
Offer a terse response. 0.76. What is the ratio of the Production index(2004-2006) in Congo (Republic) in 1968 to that in 1969?
Your response must be concise. 1.02. What is the ratio of the Production index(2004-2006) in Georgia in 1968 to that in 1969?
Your answer should be compact. 0.9. What is the ratio of the Production index(2004-2006) of Seychelles in 1968 to that in 1969?
Your answer should be compact. 1.48. What is the ratio of the Production index(2004-2006) of Uruguay in 1968 to that in 1969?
Ensure brevity in your answer.  0.84. What is the ratio of the Production index(2004-2006) in Congo (Republic) in 1968 to that in 1970?
Your answer should be very brief. 1.03. What is the ratio of the Production index(2004-2006) of Georgia in 1968 to that in 1970?
Keep it short and to the point. 1.24. What is the ratio of the Production index(2004-2006) in Seychelles in 1968 to that in 1970?
Keep it short and to the point. 1.58. What is the ratio of the Production index(2004-2006) of Uruguay in 1968 to that in 1970?
Provide a succinct answer. 0.79. What is the ratio of the Production index(2004-2006) in Congo (Republic) in 1969 to that in 1970?
Ensure brevity in your answer.  1.01. What is the ratio of the Production index(2004-2006) of Georgia in 1969 to that in 1970?
Ensure brevity in your answer.  1.38. What is the ratio of the Production index(2004-2006) in Seychelles in 1969 to that in 1970?
Offer a terse response. 1.07. What is the ratio of the Production index(2004-2006) in Uruguay in 1969 to that in 1970?
Provide a succinct answer. 0.94. What is the difference between the highest and the second highest Production index(2004-2006) of Congo (Republic)?
Your answer should be very brief. 0.44. What is the difference between the highest and the second highest Production index(2004-2006) of Seychelles?
Your response must be concise. 27.42. What is the difference between the highest and the second highest Production index(2004-2006) in Uruguay?
Offer a very short reply. 2.5. What is the difference between the highest and the lowest Production index(2004-2006) of Congo (Republic)?
Ensure brevity in your answer.  5.97. What is the difference between the highest and the lowest Production index(2004-2006) in Georgia?
Make the answer very short. 50.57. What is the difference between the highest and the lowest Production index(2004-2006) of Seychelles?
Your answer should be very brief. 163.65. What is the difference between the highest and the lowest Production index(2004-2006) in Uruguay?
Offer a very short reply. 9.73. 